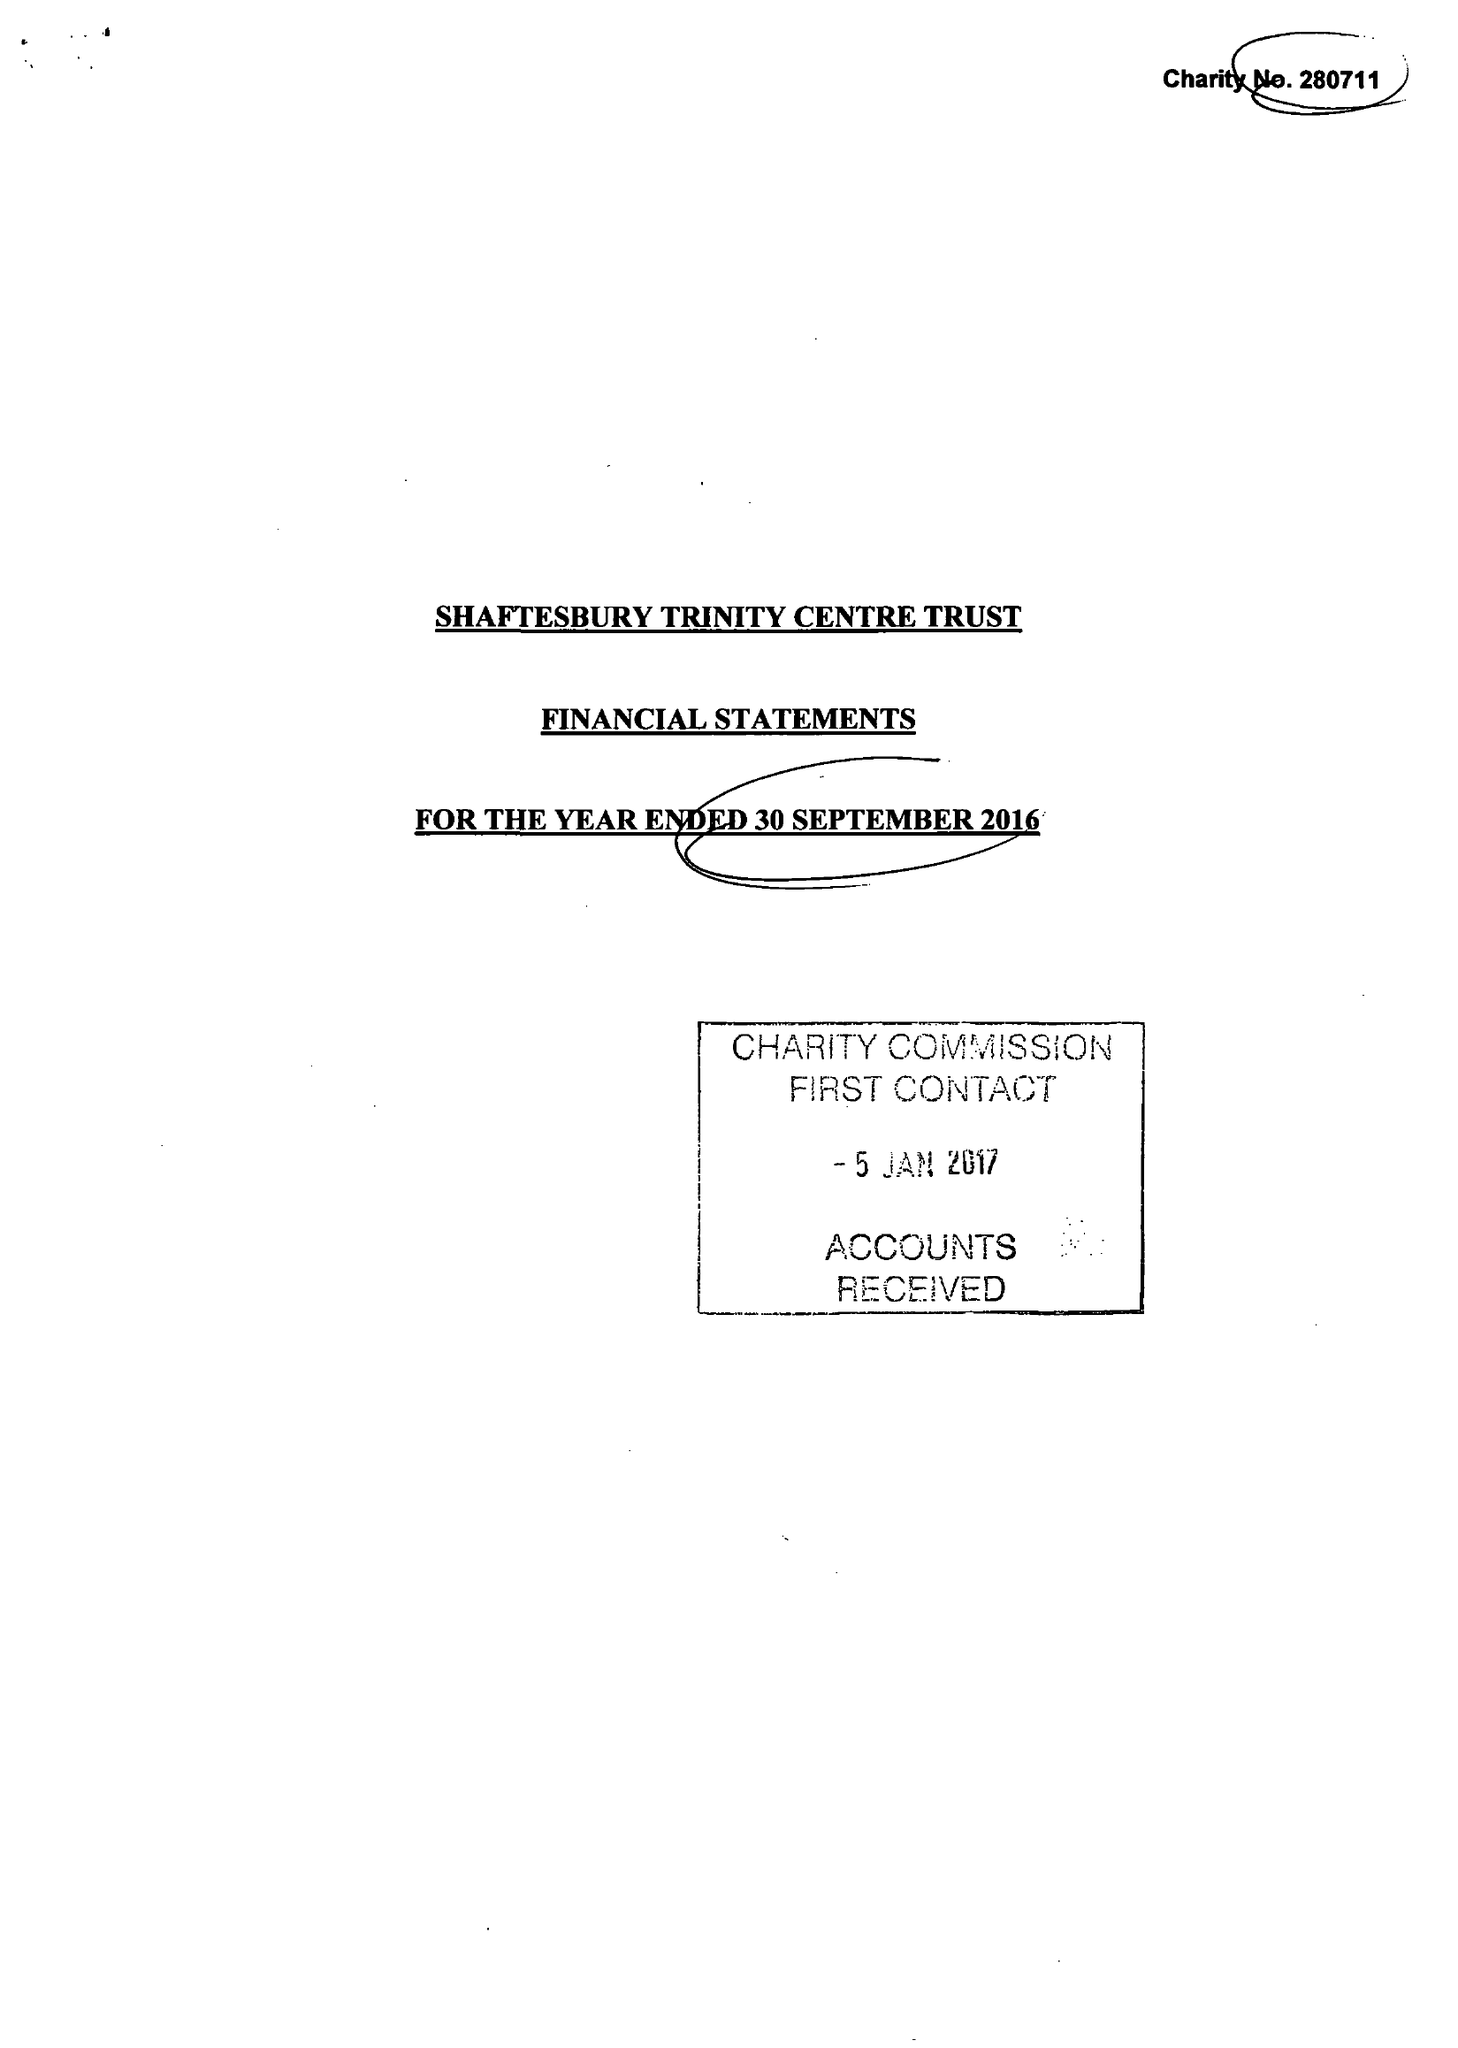What is the value for the income_annually_in_british_pounds?
Answer the question using a single word or phrase. 84886.00 